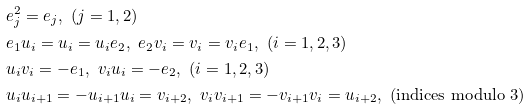Convert formula to latex. <formula><loc_0><loc_0><loc_500><loc_500>& e _ { j } ^ { 2 } = e _ { j } , \ ( j = 1 , 2 ) \\ & e _ { 1 } u _ { i } = u _ { i } = u _ { i } e _ { 2 } , \ e _ { 2 } v _ { i } = v _ { i } = v _ { i } e _ { 1 } , \ ( i = 1 , 2 , 3 ) \\ & u _ { i } v _ { i } = - e _ { 1 } , \ v _ { i } u _ { i } = - e _ { 2 } , \ ( i = 1 , 2 , 3 ) \\ & u _ { i } u _ { i + 1 } = - u _ { i + 1 } u _ { i } = v _ { i + 2 } , \ v _ { i } v _ { i + 1 } = - v _ { i + 1 } v _ { i } = u _ { i + 2 } , \ \text {(indices modulo $3$)}</formula> 